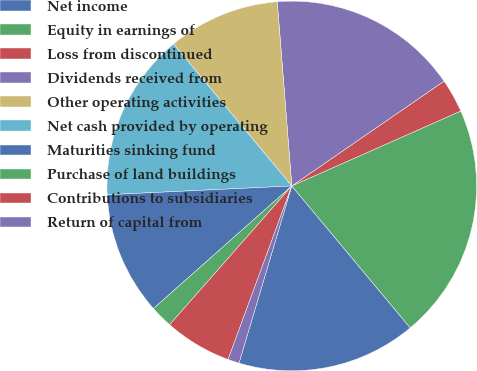<chart> <loc_0><loc_0><loc_500><loc_500><pie_chart><fcel>Net income<fcel>Equity in earnings of<fcel>Loss from discontinued<fcel>Dividends received from<fcel>Other operating activities<fcel>Net cash provided by operating<fcel>Maturities sinking fund<fcel>Purchase of land buildings<fcel>Contributions to subsidiaries<fcel>Return of capital from<nl><fcel>15.68%<fcel>20.57%<fcel>2.95%<fcel>16.66%<fcel>9.8%<fcel>14.7%<fcel>10.78%<fcel>1.97%<fcel>5.89%<fcel>0.99%<nl></chart> 